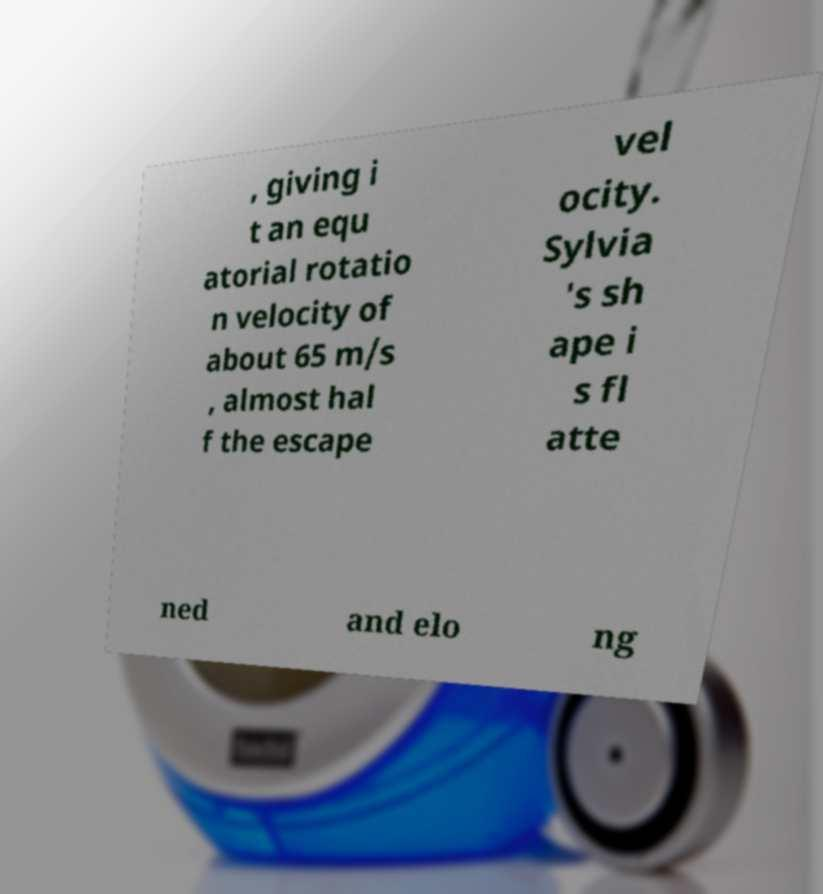I need the written content from this picture converted into text. Can you do that? , giving i t an equ atorial rotatio n velocity of about 65 m/s , almost hal f the escape vel ocity. Sylvia 's sh ape i s fl atte ned and elo ng 